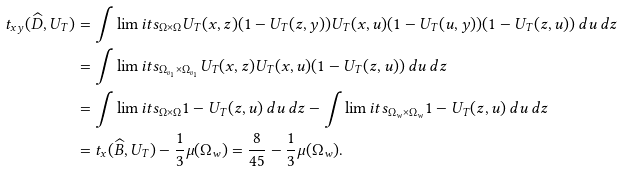Convert formula to latex. <formula><loc_0><loc_0><loc_500><loc_500>t _ { x y } ( \widehat { D } , U _ { T } ) & = \int \lim i t s _ { \Omega \times \Omega } U _ { T } ( x , z ) ( 1 - U _ { T } ( z , y ) ) U _ { T } ( x , u ) ( 1 - U _ { T } ( u , y ) ) ( 1 - U _ { T } ( z , u ) ) \, d u \, d z \\ & = \int \lim i t s _ { \Omega _ { v _ { 1 } } \times \Omega _ { v _ { 1 } } } U _ { T } ( x , z ) U _ { T } ( x , u ) ( 1 - U _ { T } ( z , u ) ) \, d u \, d z \\ & = \int \lim i t s _ { \Omega \times \Omega } 1 - U _ { T } ( z , u ) \, d u \, d z - \int \lim i t s _ { \Omega _ { w } \times \Omega _ { w } } 1 - U _ { T } ( z , u ) \, d u \, d z \\ & = t _ { x } ( \widehat { B } , U _ { T } ) - \frac { 1 } { 3 } \mu ( \Omega _ { w } ) = \frac { 8 } { 4 5 } - \frac { 1 } { 3 } \mu ( \Omega _ { w } ) .</formula> 